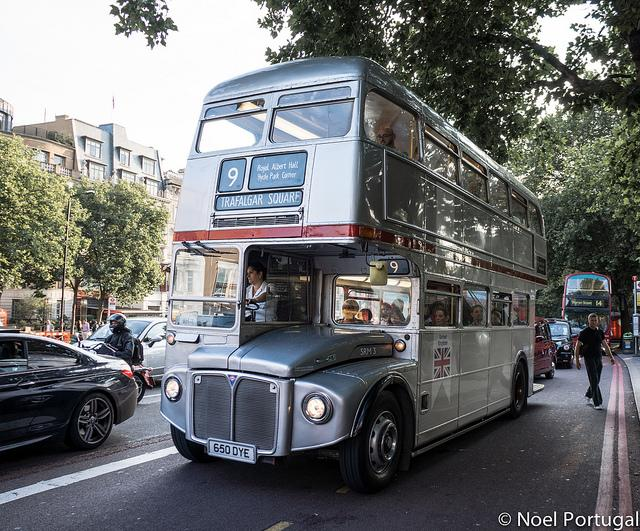In which country does this bus drive?

Choices:
A) usa
B) united kingdom
C) belgium
D) france united kingdom 